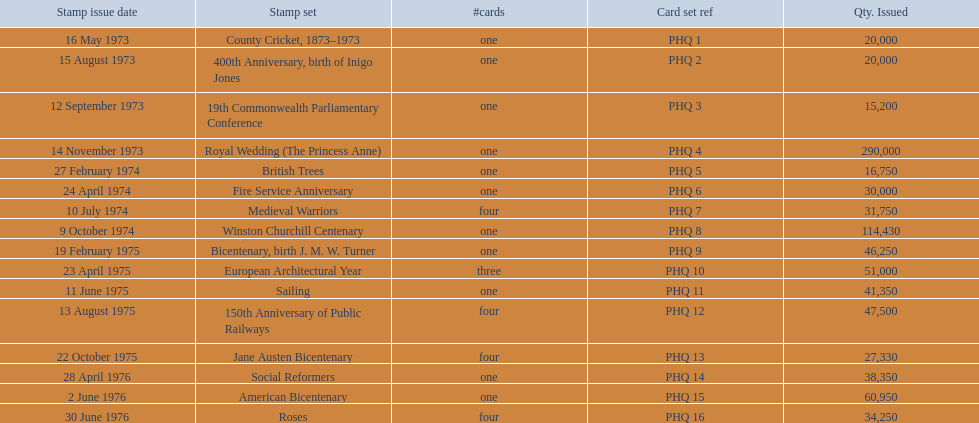Would you mind parsing the complete table? {'header': ['Stamp issue date', 'Stamp set', '#cards', 'Card set ref', 'Qty. Issued'], 'rows': [['16 May 1973', 'County Cricket, 1873–1973', 'one', 'PHQ 1', '20,000'], ['15 August 1973', '400th Anniversary, birth of Inigo Jones', 'one', 'PHQ 2', '20,000'], ['12 September 1973', '19th Commonwealth Parliamentary Conference', 'one', 'PHQ 3', '15,200'], ['14 November 1973', 'Royal Wedding (The Princess Anne)', 'one', 'PHQ 4', '290,000'], ['27 February 1974', 'British Trees', 'one', 'PHQ 5', '16,750'], ['24 April 1974', 'Fire Service Anniversary', 'one', 'PHQ 6', '30,000'], ['10 July 1974', 'Medieval Warriors', 'four', 'PHQ 7', '31,750'], ['9 October 1974', 'Winston Churchill Centenary', 'one', 'PHQ 8', '114,430'], ['19 February 1975', 'Bicentenary, birth J. M. W. Turner', 'one', 'PHQ 9', '46,250'], ['23 April 1975', 'European Architectural Year', 'three', 'PHQ 10', '51,000'], ['11 June 1975', 'Sailing', 'one', 'PHQ 11', '41,350'], ['13 August 1975', '150th Anniversary of Public Railways', 'four', 'PHQ 12', '47,500'], ['22 October 1975', 'Jane Austen Bicentenary', 'four', 'PHQ 13', '27,330'], ['28 April 1976', 'Social Reformers', 'one', 'PHQ 14', '38,350'], ['2 June 1976', 'American Bicentenary', 'one', 'PHQ 15', '60,950'], ['30 June 1976', 'Roses', 'four', 'PHQ 16', '34,250']]} What are the complete stamp collections? County Cricket, 1873–1973, 400th Anniversary, birth of Inigo Jones, 19th Commonwealth Parliamentary Conference, Royal Wedding (The Princess Anne), British Trees, Fire Service Anniversary, Medieval Warriors, Winston Churchill Centenary, Bicentenary, birth J. M. W. Turner, European Architectural Year, Sailing, 150th Anniversary of Public Railways, Jane Austen Bicentenary, Social Reformers, American Bicentenary, Roses. For these collections, what were the amounts released? 20,000, 20,000, 15,200, 290,000, 16,750, 30,000, 31,750, 114,430, 46,250, 51,000, 41,350, 47,500, 27,330, 38,350, 60,950, 34,250. Of these, which amount exceeds 200,000? 290,000. What is the stamp collection associated with this amount? Royal Wedding (The Princess Anne). 